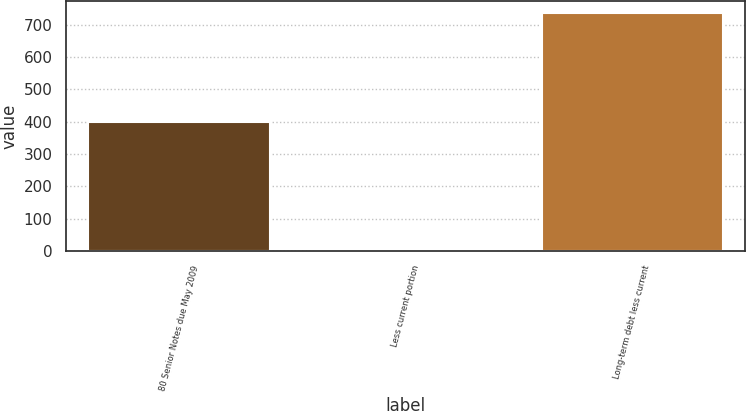<chart> <loc_0><loc_0><loc_500><loc_500><bar_chart><fcel>80 Senior Notes due May 2009<fcel>Less current portion<fcel>Long-term debt less current<nl><fcel>400<fcel>4<fcel>736<nl></chart> 